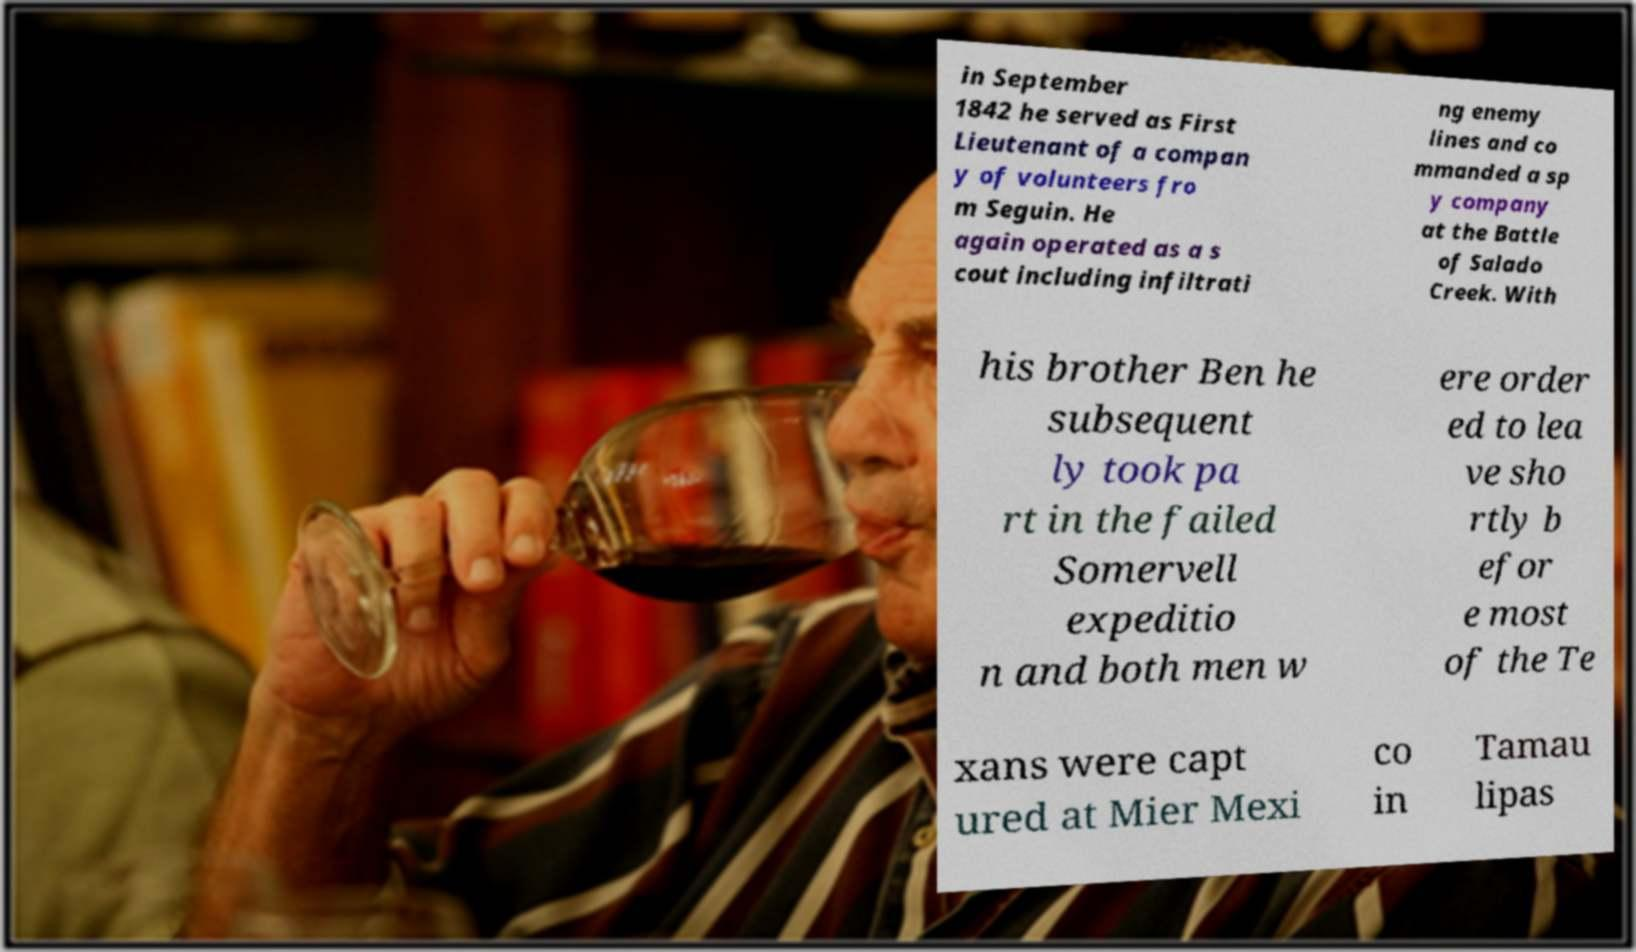Please identify and transcribe the text found in this image. in September 1842 he served as First Lieutenant of a compan y of volunteers fro m Seguin. He again operated as a s cout including infiltrati ng enemy lines and co mmanded a sp y company at the Battle of Salado Creek. With his brother Ben he subsequent ly took pa rt in the failed Somervell expeditio n and both men w ere order ed to lea ve sho rtly b efor e most of the Te xans were capt ured at Mier Mexi co in Tamau lipas 